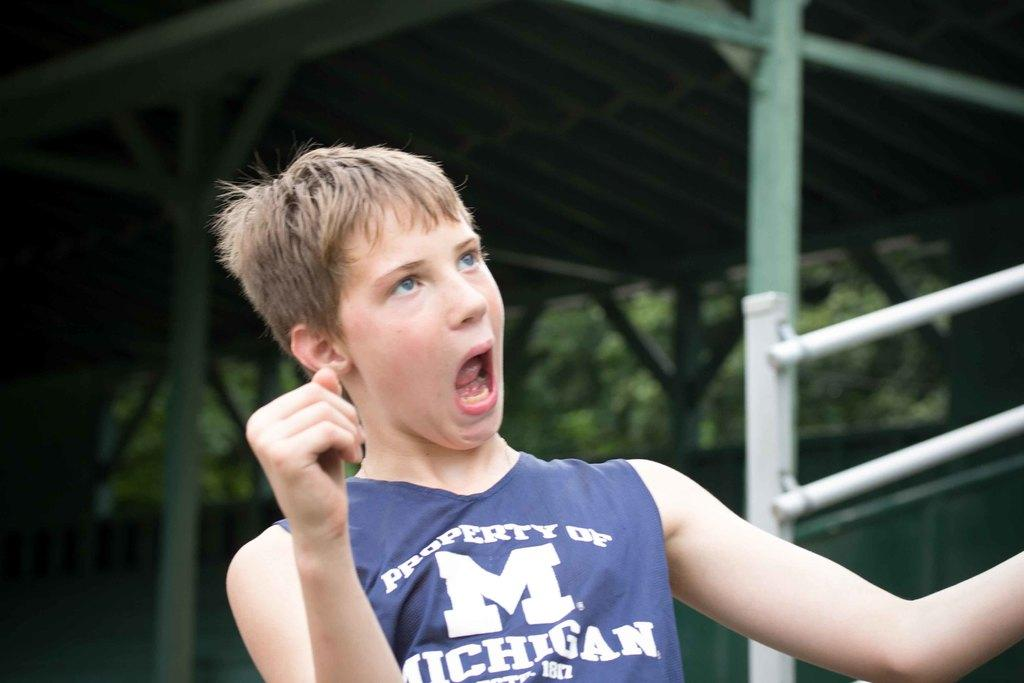<image>
Create a compact narrative representing the image presented. A boy with the letter M on his vest looks surprised. 